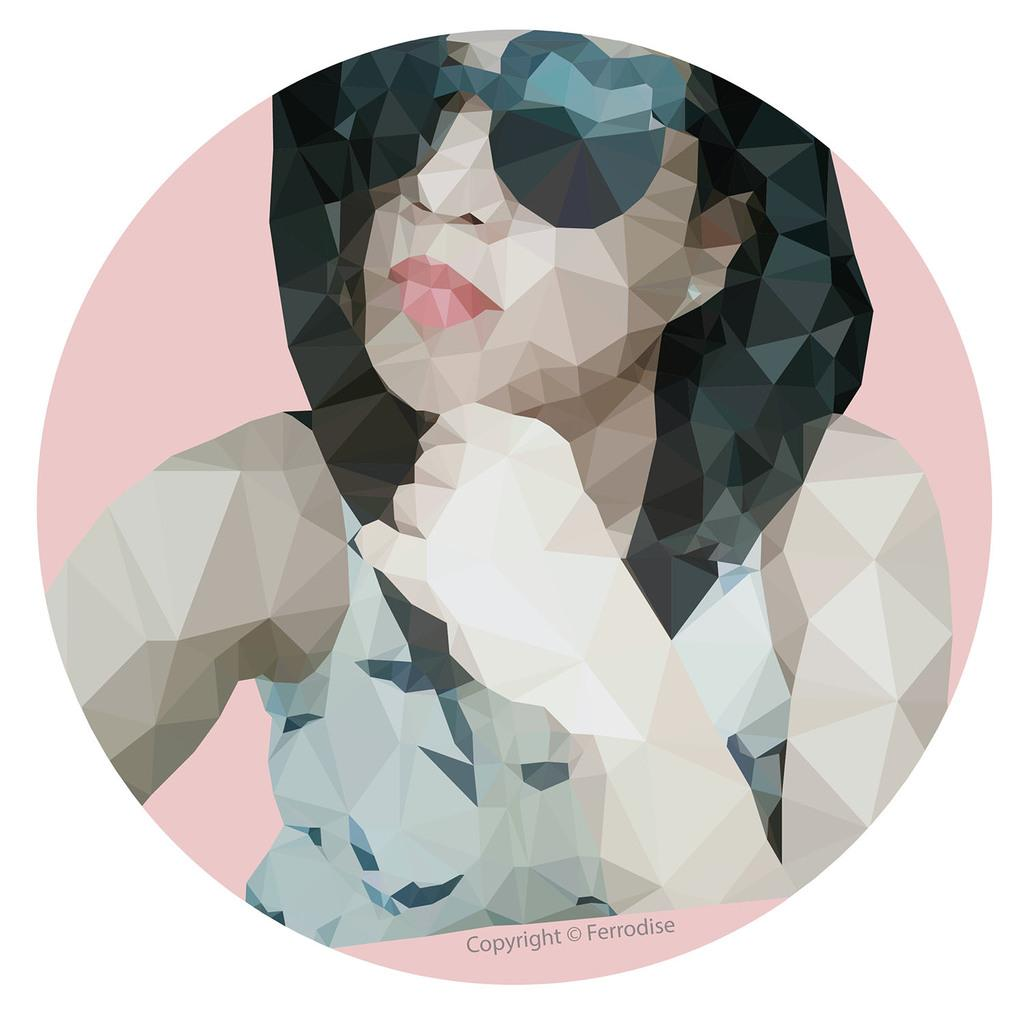What is the main subject of the image? The main subject of the image is a picture of a woman. What accessory is the woman wearing in the picture? The woman in the picture is wearing glasses. How would you describe the background color scheme in the image? The background of the image is in white and pink colors. Can you see any windows or seashores in the image? There are no windows or seashores visible in the image; it features a picture of a woman with glasses against a white and pink background. Is there a mine present in the image? There is no mine present in the image. 